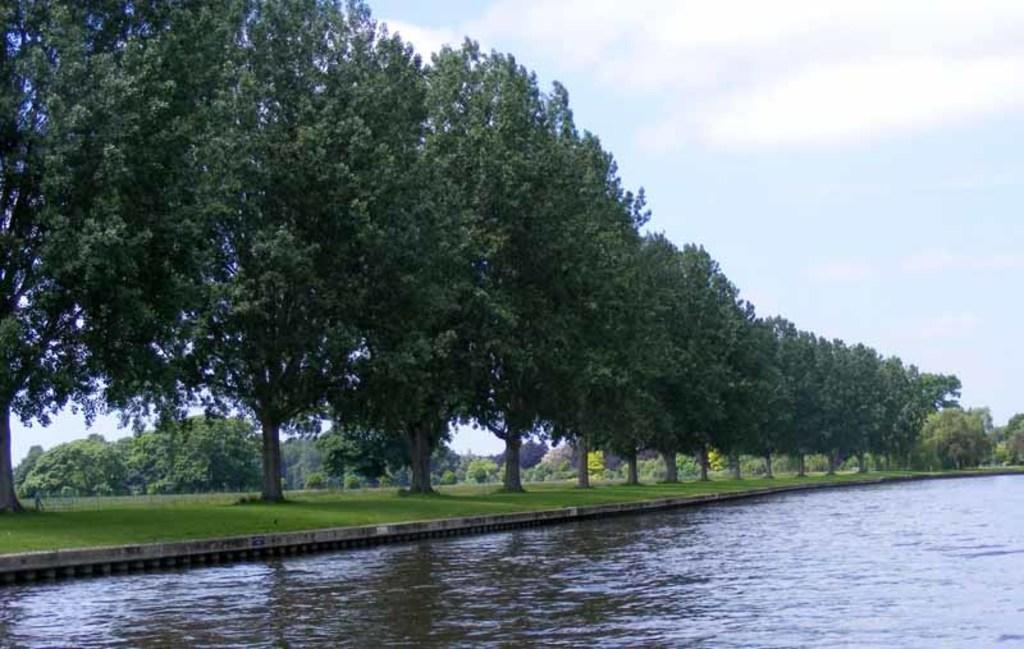How would you summarize this image in a sentence or two? In this image, we can see so many trees and grass. At the bottom, we can see the water. Background there is a water. 